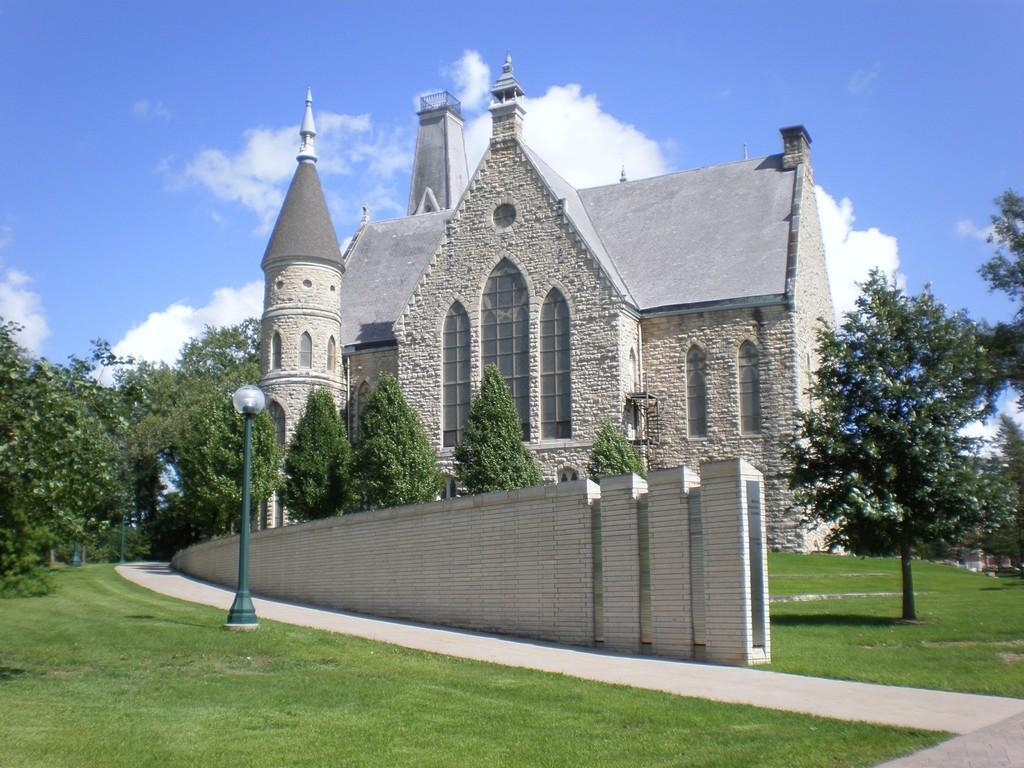In one or two sentences, can you explain what this image depicts? In this image we can see a house, windows, there is a light pole, there are plants, trees, also we can see the wall, and the sky. 